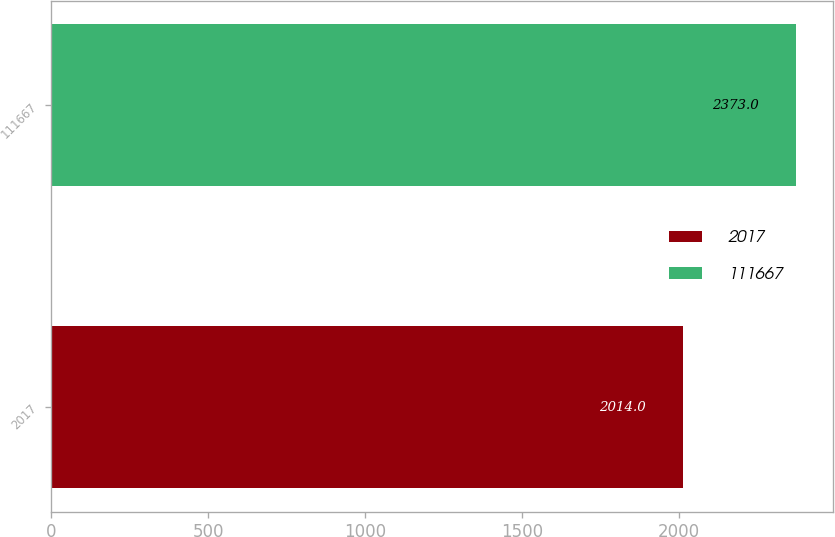Convert chart. <chart><loc_0><loc_0><loc_500><loc_500><bar_chart><fcel>2017<fcel>111667<nl><fcel>2014<fcel>2373<nl></chart> 